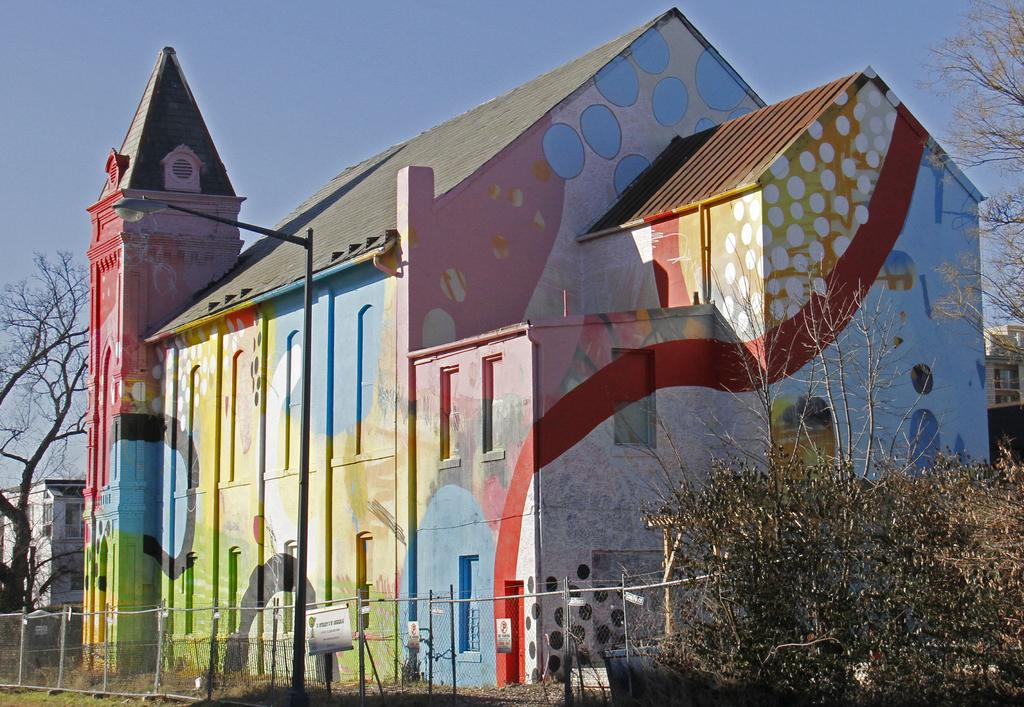What type of structure is visible in the image? There is a house in the image. What can be seen in front of the house? There are trees in front of the house. What is located behind the house? There is a building and a tree behind the house. Can you tell me how many bees are sitting on the wall behind the house in the image? There is no wall or bees present in the image; it only shows a house with trees in front and a building and tree behind it. 